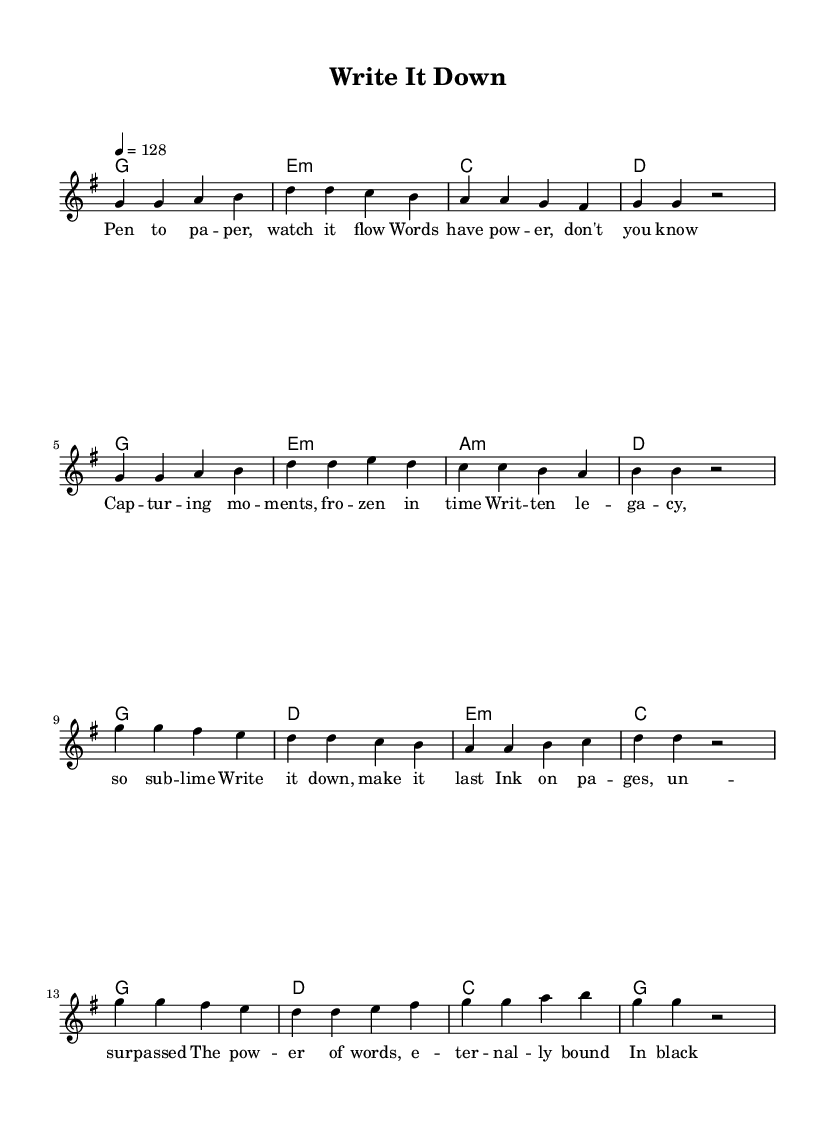What is the key signature of this music? The key signature is G major, which has one sharp (F#). This can be identified by locating the key signature at the beginning of the staff.
Answer: G major What is the time signature of this music? The time signature is 4/4, indicated at the beginning of the music. This means there are four beats in each measure, and a quarter note gets one beat.
Answer: 4/4 What is the tempo marking of this piece? The tempo marking is 128 beats per minute, indicated by the tempo indication "4 = 128." This shows the intended speed of the music.
Answer: 128 How many measures are in the verse section? The verse section consists of 8 measures. This can be counted from the melody portion where the verses are indicated, totaling the measures.
Answer: 8 What is the first lyric of the chorus? The first lyric of the chorus is "Write it down." This can be extracted from the lyric section, following the division between verse and chorus.
Answer: Write it down What is the harmonic progression of the chorus? The harmonic progression of the chorus is G, D, E minor, C. This is discerned by looking at the chord symbols above the corresponding melody notes in the chorus section.
Answer: G, D, E minor, C Which musical phrase emphasizes the power of words? The phrase "The power of words, eternally bound" emphasizes the power of words, found in the chorus lyrics. This phrase highlights the central theme of the lyrics regarding written words.
Answer: The power of words, eternally bound 